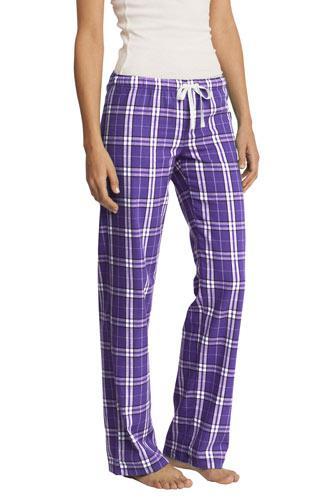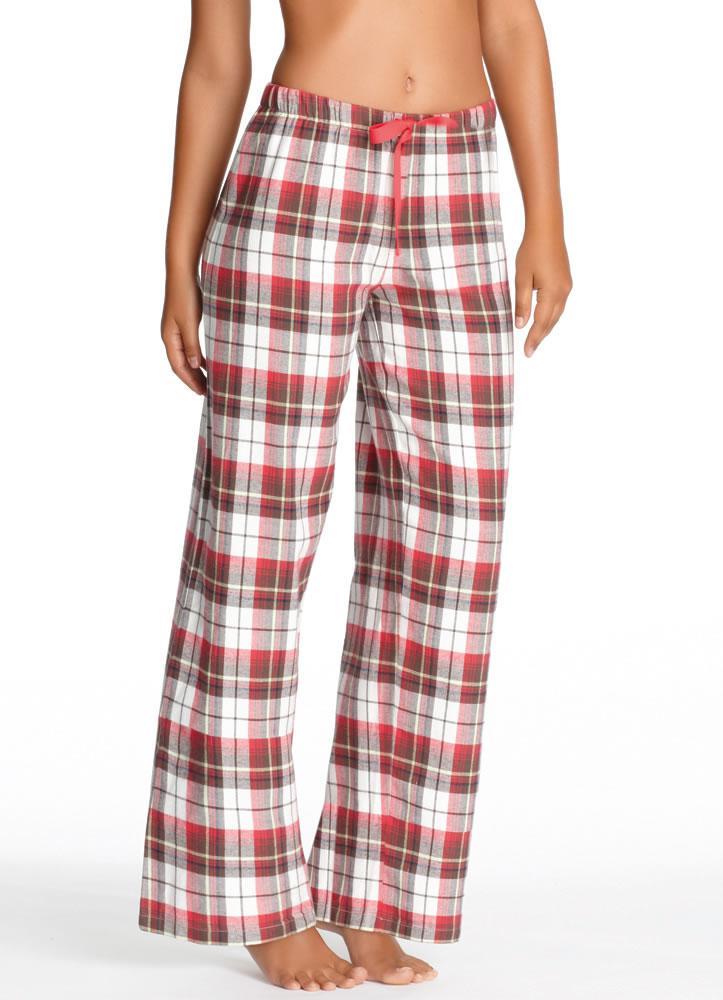The first image is the image on the left, the second image is the image on the right. Evaluate the accuracy of this statement regarding the images: "There is a woman with her hand on her hips and her shoulder sticking out.". Is it true? Answer yes or no. No. 